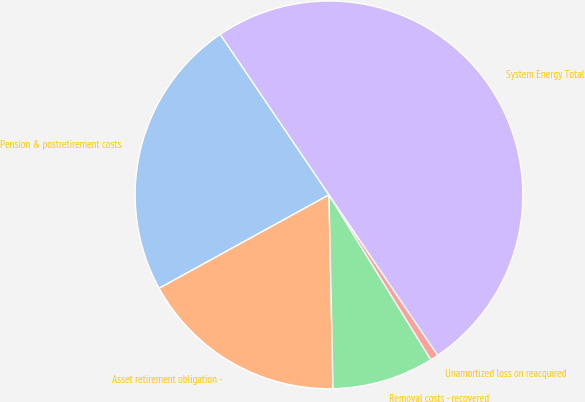Convert chart. <chart><loc_0><loc_0><loc_500><loc_500><pie_chart><fcel>Pension & postretirement costs<fcel>Asset retirement obligation -<fcel>Removal costs - recovered<fcel>Unamortized loss on reacquired<fcel>System Energy Total<nl><fcel>23.53%<fcel>17.33%<fcel>8.48%<fcel>0.67%<fcel>50.0%<nl></chart> 